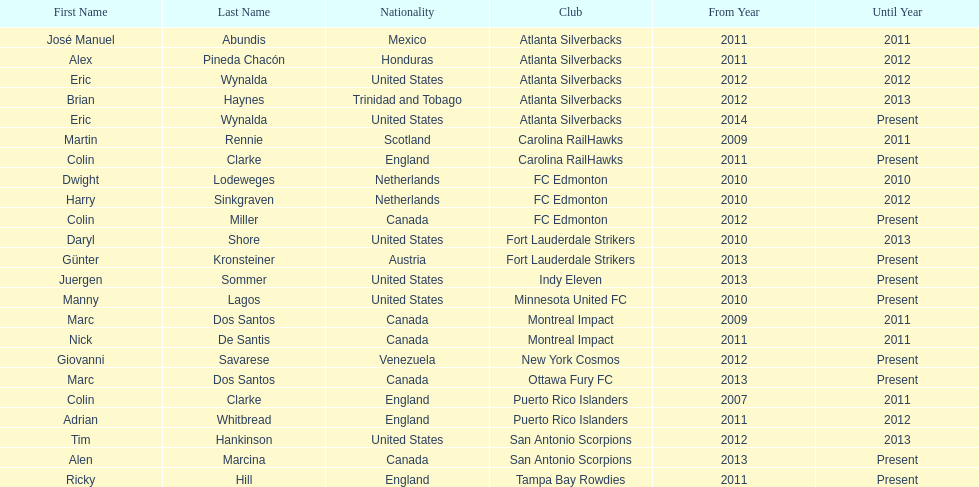Who is the last to coach the san antonio scorpions? Alen Marcina. 